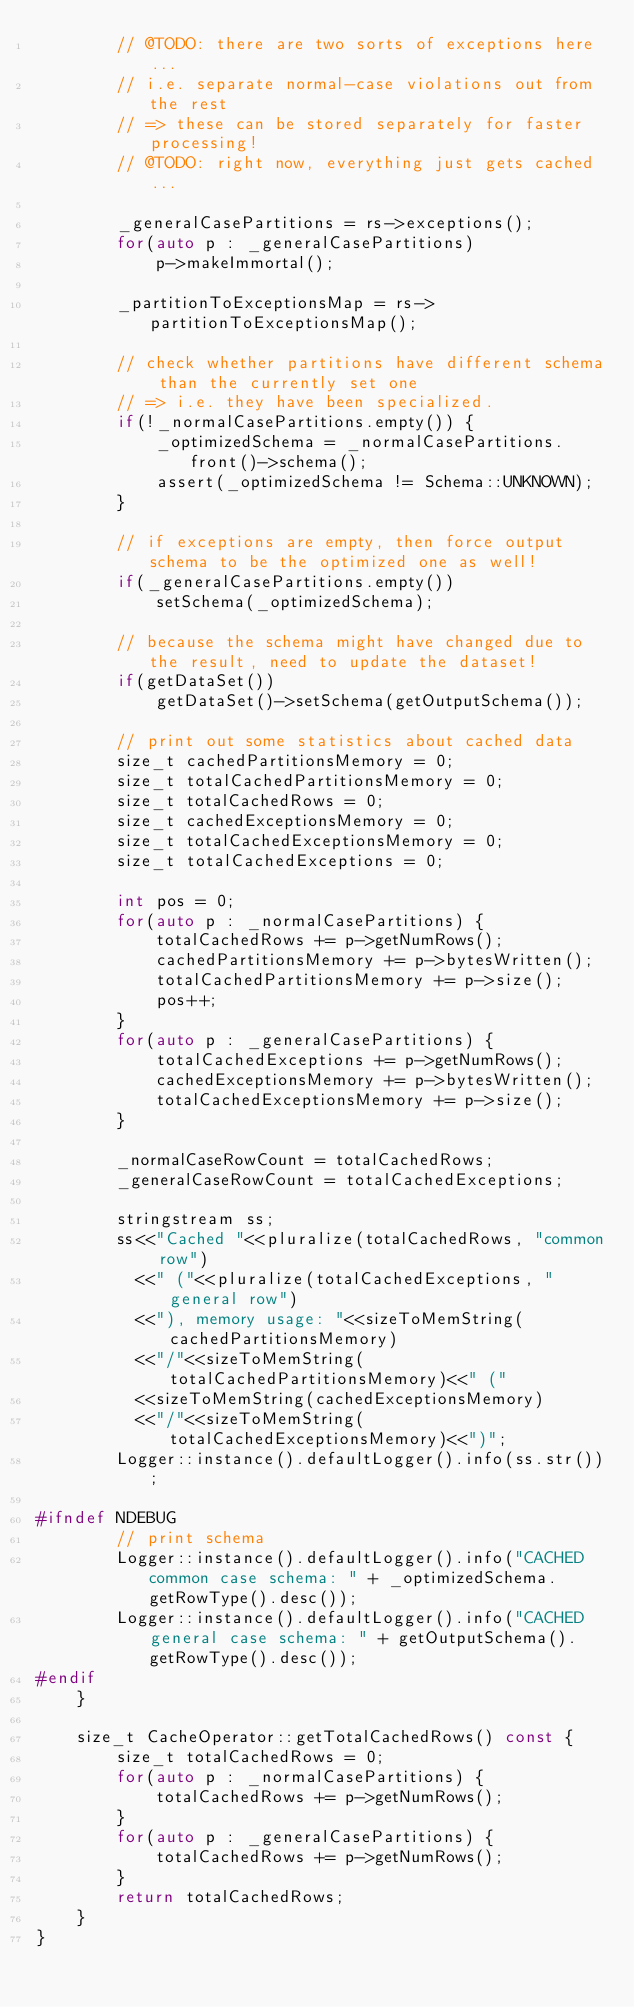Convert code to text. <code><loc_0><loc_0><loc_500><loc_500><_C++_>        // @TODO: there are two sorts of exceptions here...
        // i.e. separate normal-case violations out from the rest
        // => these can be stored separately for faster processing!
        // @TODO: right now, everything just gets cached...

        _generalCasePartitions = rs->exceptions();
        for(auto p : _generalCasePartitions)
            p->makeImmortal();

        _partitionToExceptionsMap = rs->partitionToExceptionsMap();

        // check whether partitions have different schema than the currently set one
        // => i.e. they have been specialized.
        if(!_normalCasePartitions.empty()) {
            _optimizedSchema = _normalCasePartitions.front()->schema();
            assert(_optimizedSchema != Schema::UNKNOWN);
        }

        // if exceptions are empty, then force output schema to be the optimized one as well!
        if(_generalCasePartitions.empty())
            setSchema(_optimizedSchema);

        // because the schema might have changed due to the result, need to update the dataset!
        if(getDataSet())
            getDataSet()->setSchema(getOutputSchema());

        // print out some statistics about cached data
        size_t cachedPartitionsMemory = 0;
        size_t totalCachedPartitionsMemory = 0;
        size_t totalCachedRows = 0;
        size_t cachedExceptionsMemory = 0;
        size_t totalCachedExceptionsMemory = 0;
        size_t totalCachedExceptions = 0;

        int pos = 0;
        for(auto p : _normalCasePartitions) {
            totalCachedRows += p->getNumRows();
            cachedPartitionsMemory += p->bytesWritten();
            totalCachedPartitionsMemory += p->size();
            pos++;
        }
        for(auto p : _generalCasePartitions) {
            totalCachedExceptions += p->getNumRows();
            cachedExceptionsMemory += p->bytesWritten();
            totalCachedExceptionsMemory += p->size();
        }

        _normalCaseRowCount = totalCachedRows;
        _generalCaseRowCount = totalCachedExceptions;

        stringstream ss;
        ss<<"Cached "<<pluralize(totalCachedRows, "common row")
          <<" ("<<pluralize(totalCachedExceptions, "general row")
          <<"), memory usage: "<<sizeToMemString(cachedPartitionsMemory)
          <<"/"<<sizeToMemString(totalCachedPartitionsMemory)<<" ("
          <<sizeToMemString(cachedExceptionsMemory)
          <<"/"<<sizeToMemString(totalCachedExceptionsMemory)<<")";
        Logger::instance().defaultLogger().info(ss.str());

#ifndef NDEBUG
        // print schema
        Logger::instance().defaultLogger().info("CACHED common case schema: " + _optimizedSchema.getRowType().desc());
        Logger::instance().defaultLogger().info("CACHED general case schema: " + getOutputSchema().getRowType().desc());
#endif
    }

    size_t CacheOperator::getTotalCachedRows() const {
        size_t totalCachedRows = 0;
        for(auto p : _normalCasePartitions) {
            totalCachedRows += p->getNumRows();
        }
        for(auto p : _generalCasePartitions) {
            totalCachedRows += p->getNumRows();
        }
        return totalCachedRows;
    }
}</code> 